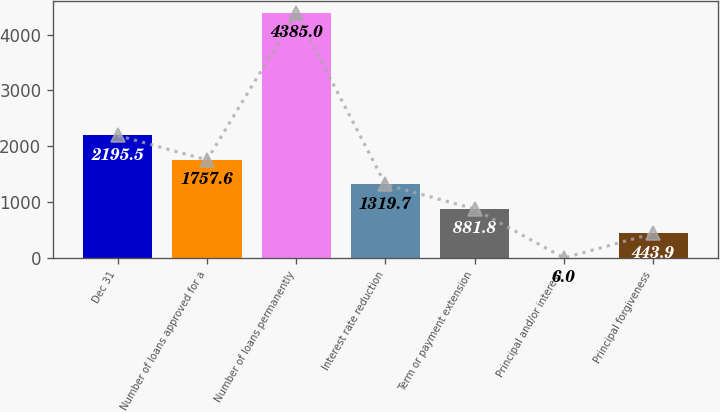Convert chart to OTSL. <chart><loc_0><loc_0><loc_500><loc_500><bar_chart><fcel>Dec 31<fcel>Number of loans approved for a<fcel>Number of loans permanently<fcel>Interest rate reduction<fcel>Term or payment extension<fcel>Principal and/or interest<fcel>Principal forgiveness<nl><fcel>2195.5<fcel>1757.6<fcel>4385<fcel>1319.7<fcel>881.8<fcel>6<fcel>443.9<nl></chart> 